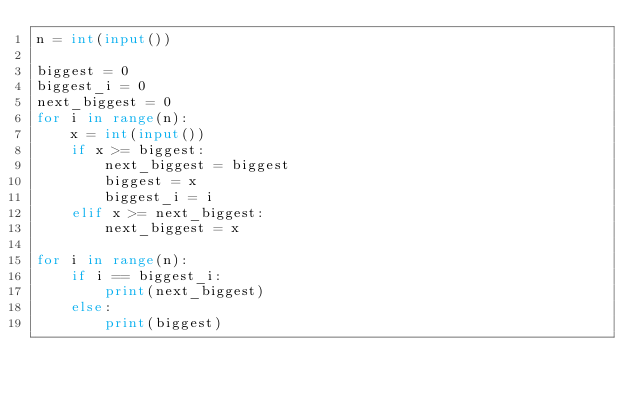<code> <loc_0><loc_0><loc_500><loc_500><_Python_>n = int(input())

biggest = 0
biggest_i = 0
next_biggest = 0
for i in range(n):
    x = int(input())
    if x >= biggest:
        next_biggest = biggest
        biggest = x
        biggest_i = i
    elif x >= next_biggest:
        next_biggest = x

for i in range(n):
    if i == biggest_i:
        print(next_biggest)
    else:
        print(biggest)
</code> 